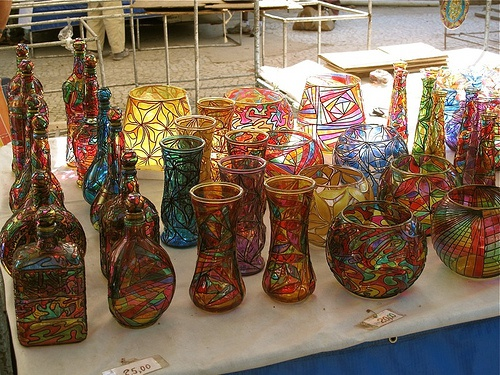Describe the objects in this image and their specific colors. I can see vase in brown, black, maroon, olive, and tan tones, vase in brown, maroon, black, olive, and gray tones, bottle in brown, black, maroon, olive, and gray tones, bottle in brown, maroon, black, olive, and gray tones, and vase in brown, maroon, and black tones in this image. 